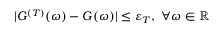Convert formula to latex. <formula><loc_0><loc_0><loc_500><loc_500>| { G } ^ { ( T ) } ( \omega ) - { G } ( \omega ) | \leq \varepsilon _ { T } , \forall \omega \in \mathbb { R }</formula> 